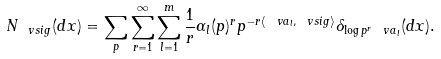<formula> <loc_0><loc_0><loc_500><loc_500>N _ { \ v s i g } ( d x ) = \sum _ { p } \sum _ { r = 1 } ^ { \infty } \sum _ { l = 1 } ^ { m } \frac { 1 } { r } \alpha _ { l } ( p ) ^ { r } p ^ { - r \langle \ v a _ { l } , \ v s i g \rangle } \delta _ { \log p ^ { r } \ v a _ { l } } ( d x ) .</formula> 